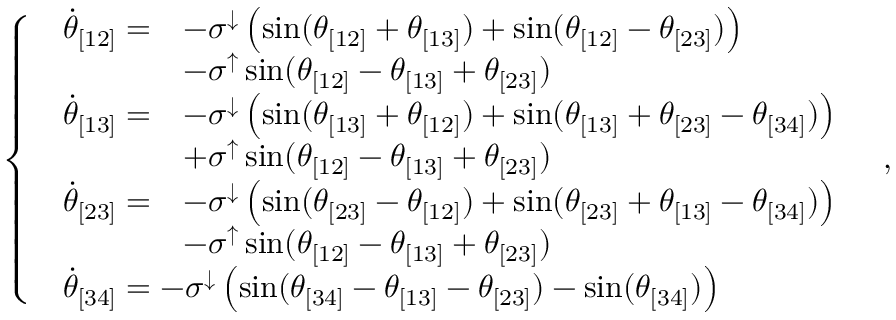<formula> <loc_0><loc_0><loc_500><loc_500>\left \{ \begin{array} { l l } { \begin{array} { r l } { \ D o t { \theta } _ { [ 1 2 ] } = } & { - \sigma ^ { \downarrow } \left ( \sin ( \theta _ { [ 1 2 ] } + \theta _ { [ 1 3 ] } ) + \sin ( \theta _ { [ 1 2 ] } - \theta _ { [ 2 3 ] } ) \right ) } \\ & { - \sigma ^ { \uparrow } \sin ( \theta _ { [ 1 2 ] } - \theta _ { [ 1 3 ] } + \theta _ { [ 2 3 ] } ) } \end{array} } \\ { \begin{array} { r l } { \ D o t { \theta } _ { [ 1 3 ] } = } & { - \sigma ^ { \downarrow } \left ( \sin ( \theta _ { [ 1 3 ] } + \theta _ { [ 1 2 ] } ) + \sin ( \theta _ { [ 1 3 ] } + \theta _ { [ 2 3 ] } - \theta _ { [ 3 4 ] } ) \right ) } \\ & { + \sigma ^ { \uparrow } \sin ( \theta _ { [ 1 2 ] } - \theta _ { [ 1 3 ] } + \theta _ { [ 2 3 ] } ) } \end{array} } \\ { \begin{array} { r l } { \ D o t { \theta } _ { [ 2 3 ] } = } & { - \sigma ^ { \downarrow } \left ( \sin ( \theta _ { [ 2 3 ] } - \theta _ { [ 1 2 ] } ) + \sin ( \theta _ { [ 2 3 ] } + \theta _ { [ 1 3 ] } - \theta _ { [ 3 4 ] } ) \right ) } \\ & { - \sigma ^ { \uparrow } \sin ( \theta _ { [ 1 2 ] } - \theta _ { [ 1 3 ] } + \theta _ { [ 2 3 ] } ) } \end{array} } \\ { \begin{array} { r } { \ D o t { \theta } _ { [ 3 4 ] } = - \sigma ^ { \downarrow } \left ( \sin ( \theta _ { [ 3 4 ] } - \theta _ { [ 1 3 ] } - \theta _ { [ 2 3 ] } ) - \sin ( \theta _ { [ 3 4 ] } ) \right ) } \end{array} } \end{array} \, ,</formula> 